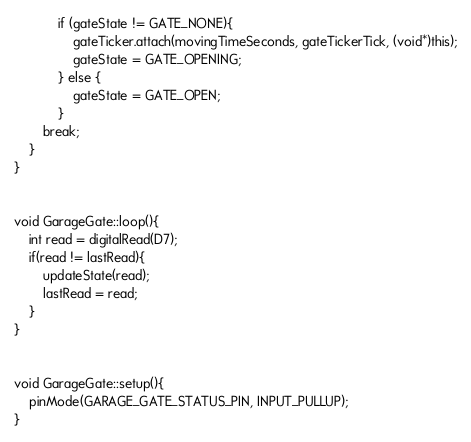<code> <loc_0><loc_0><loc_500><loc_500><_C++_>			if (gateState != GATE_NONE){
				gateTicker.attach(movingTimeSeconds, gateTickerTick, (void*)this);
				gateState = GATE_OPENING;
			} else {
				gateState = GATE_OPEN;
			}
		break;
	}
}


void GarageGate::loop(){
	int read = digitalRead(D7);
	if(read != lastRead){
		updateState(read);
		lastRead = read;
	}
}


void GarageGate::setup(){
	pinMode(GARAGE_GATE_STATUS_PIN, INPUT_PULLUP);
}
</code> 